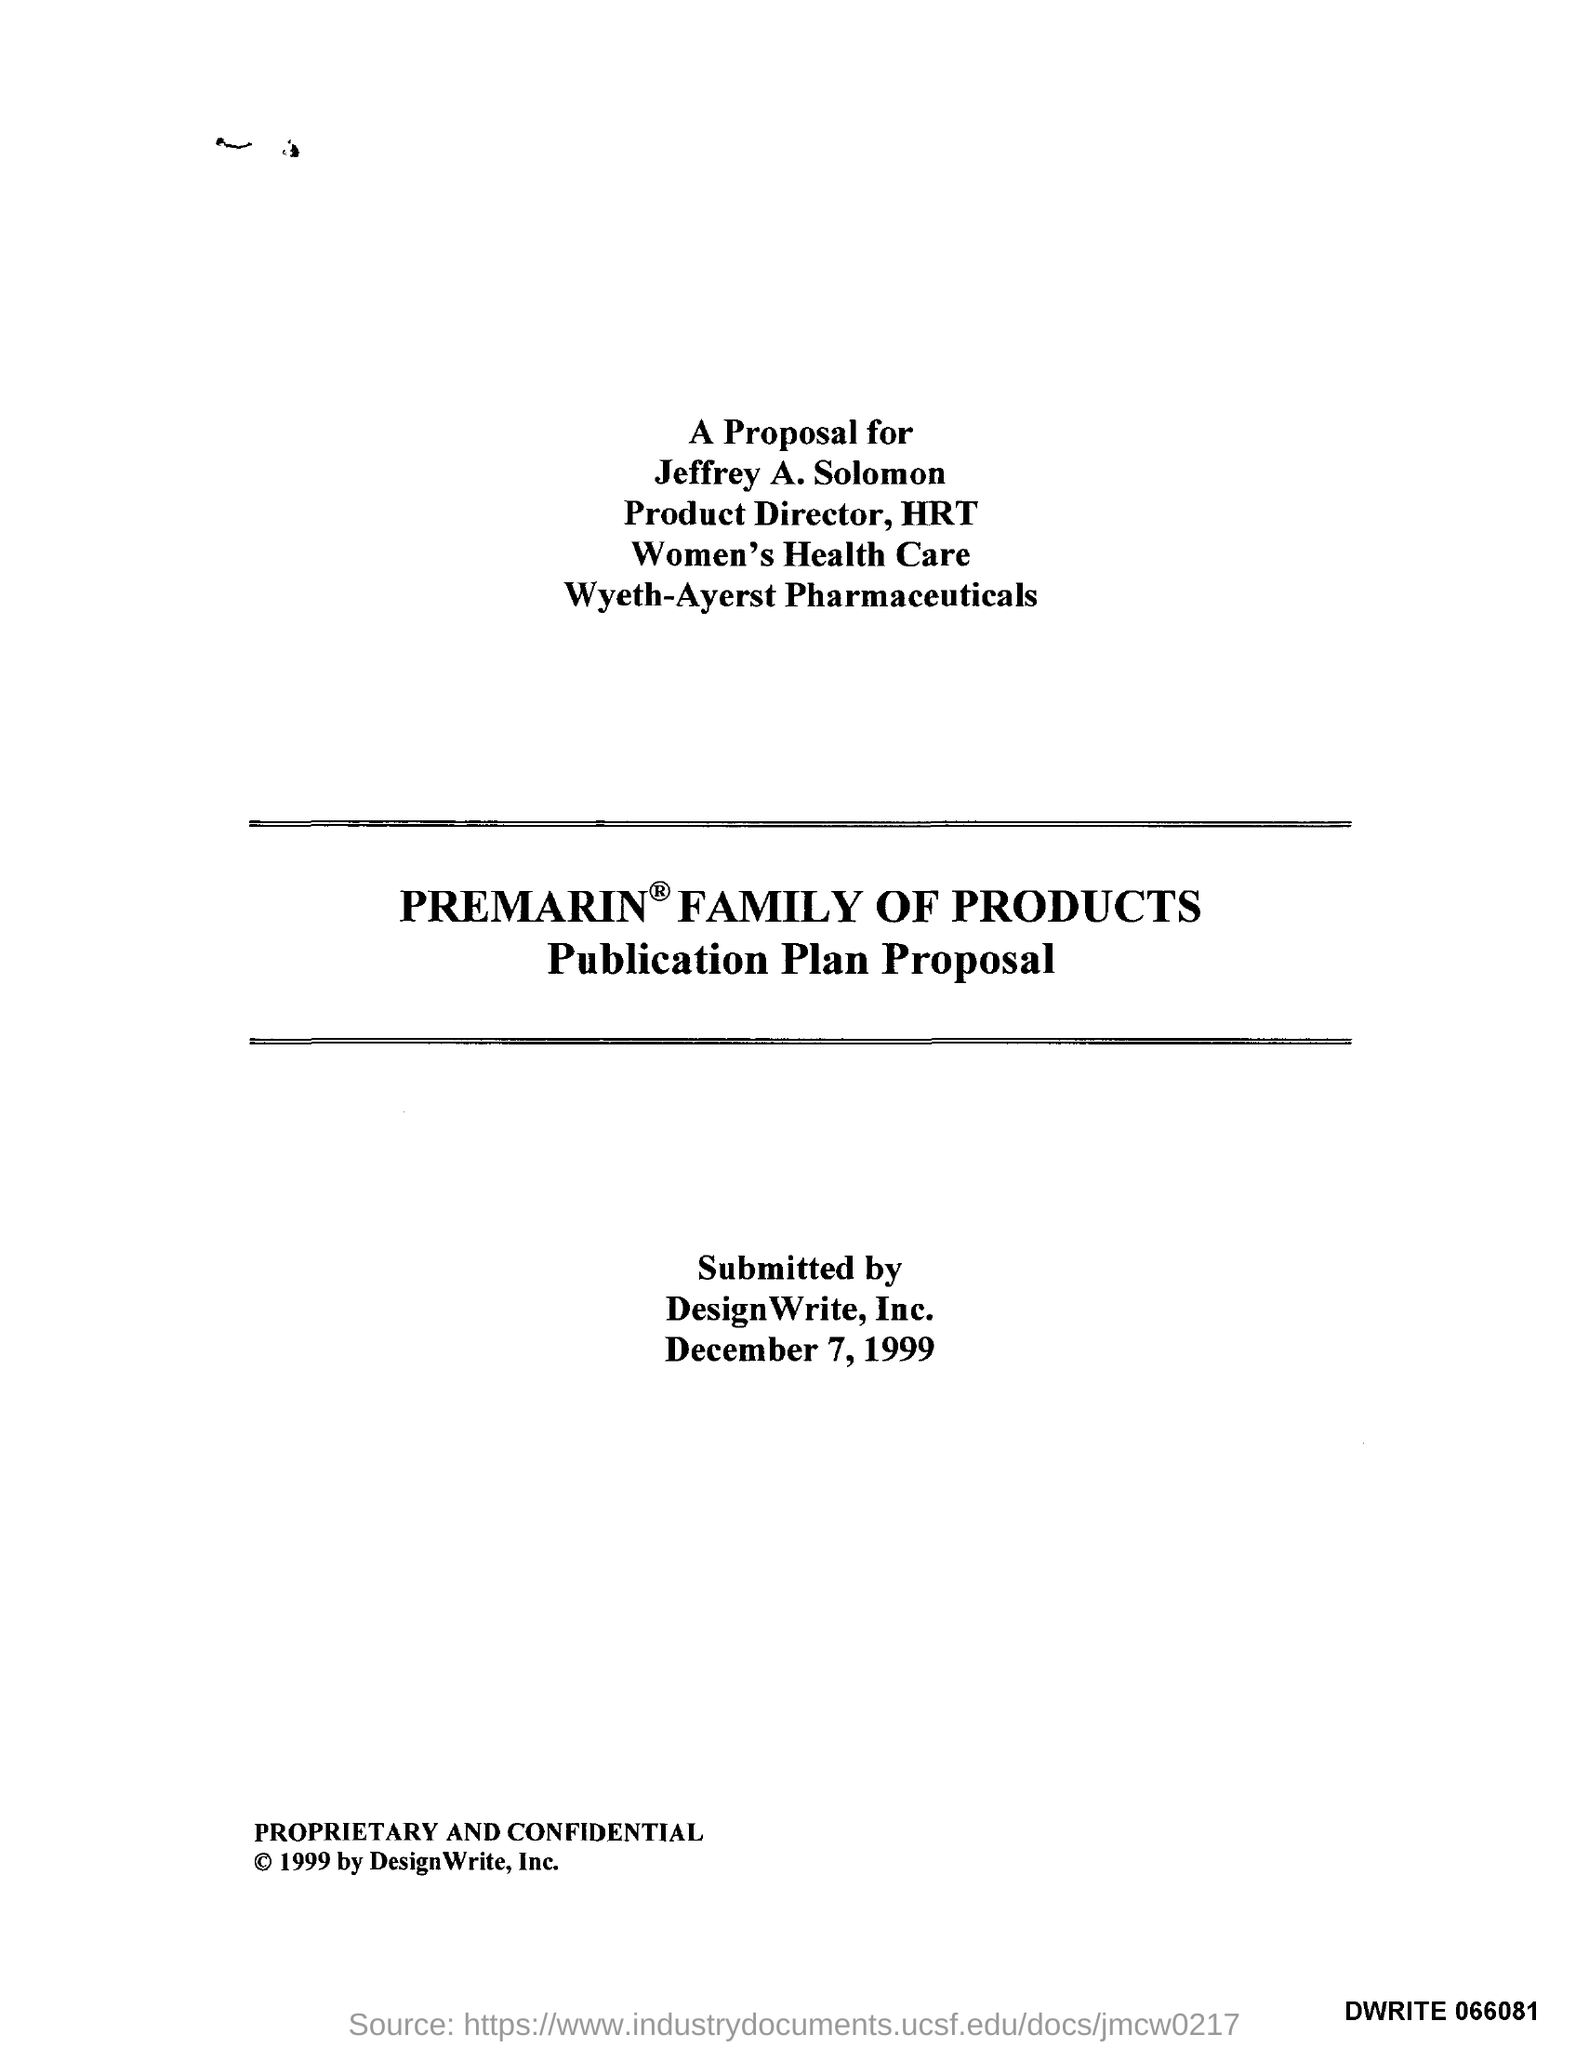What is submitted date?
Your answer should be compact. December 7, 1999. To whom the proposal is meant for?
Ensure brevity in your answer.  Jeffrey A. Solomon. 